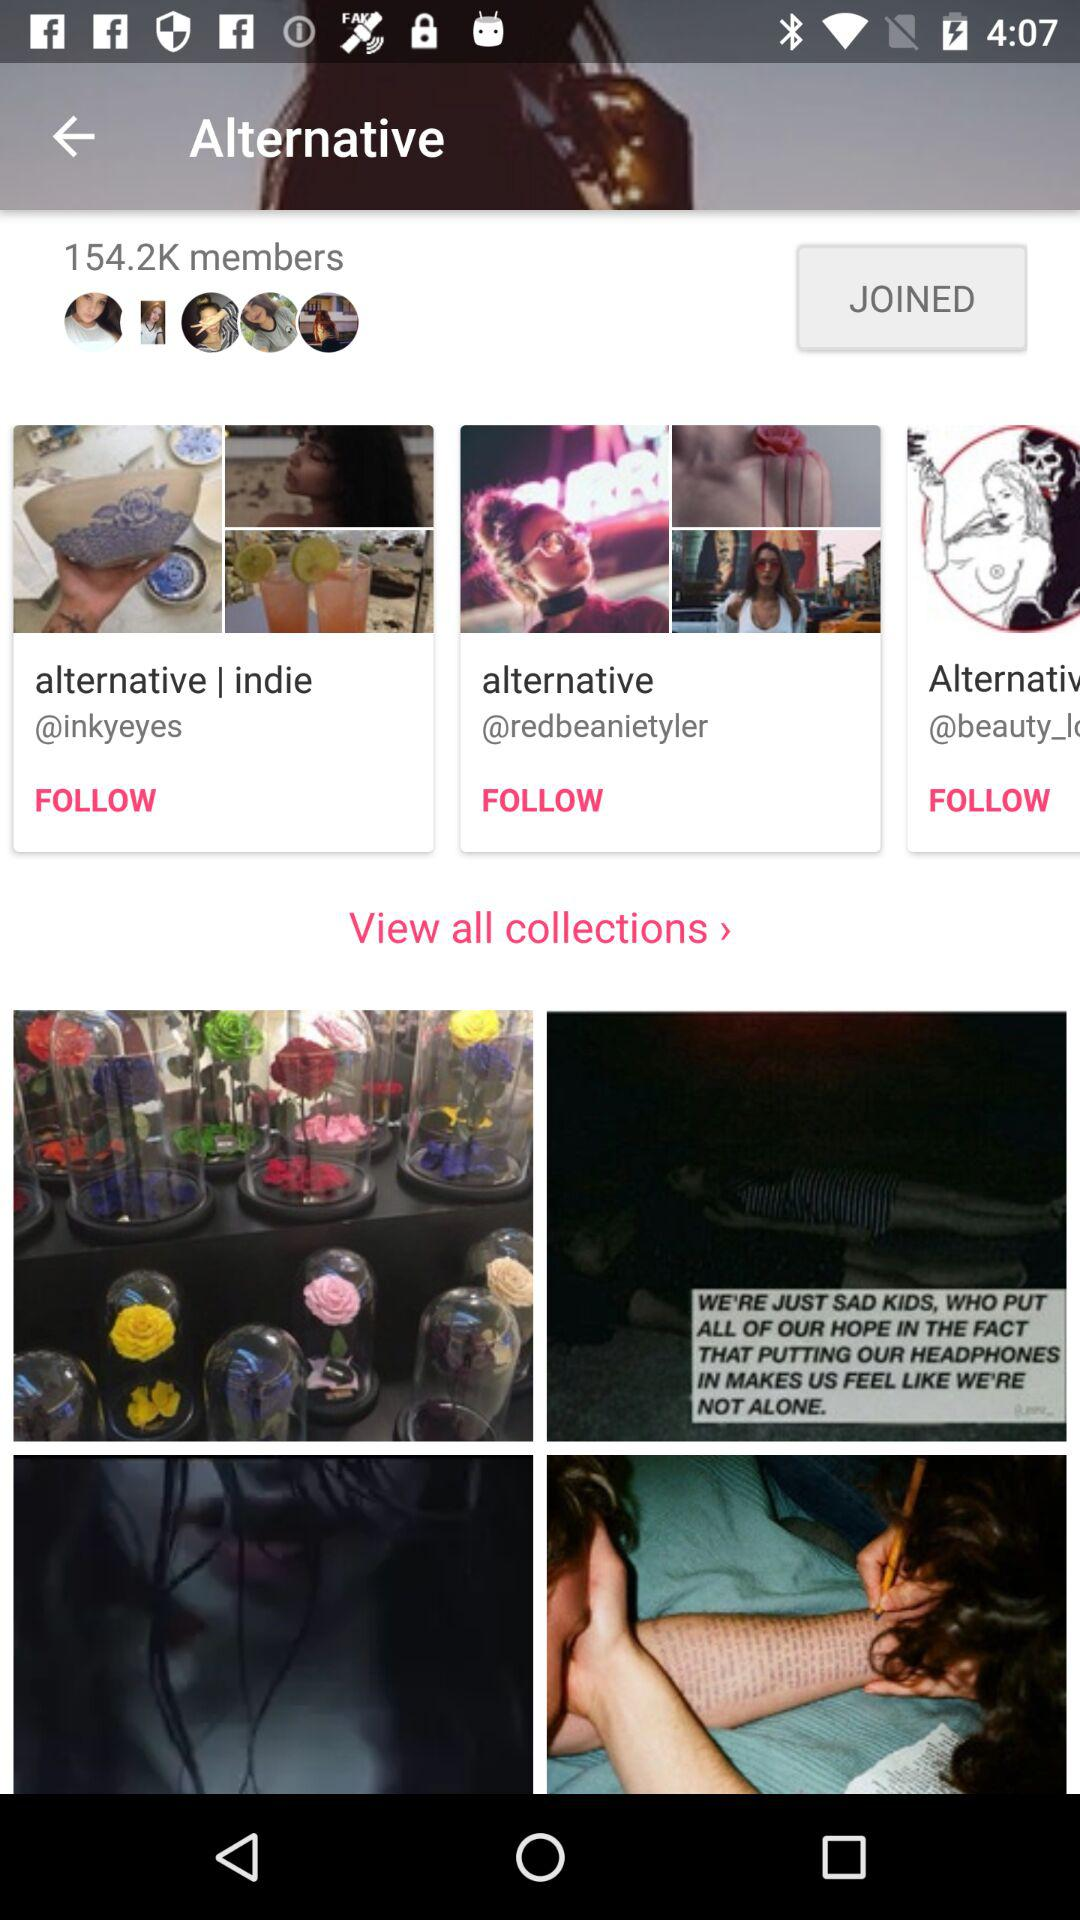How many members are there? There are 154.2K members. 